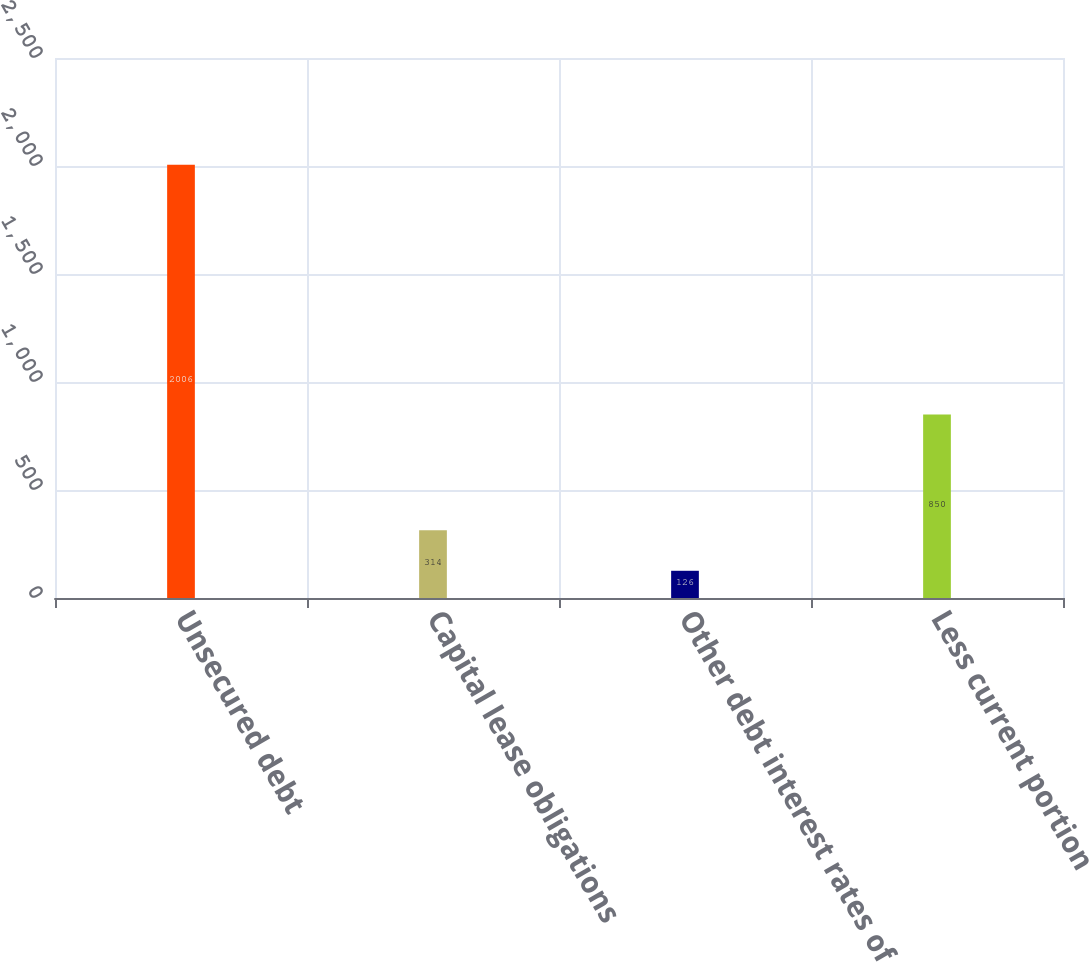Convert chart. <chart><loc_0><loc_0><loc_500><loc_500><bar_chart><fcel>Unsecured debt<fcel>Capital lease obligations<fcel>Other debt interest rates of<fcel>Less current portion<nl><fcel>2006<fcel>314<fcel>126<fcel>850<nl></chart> 